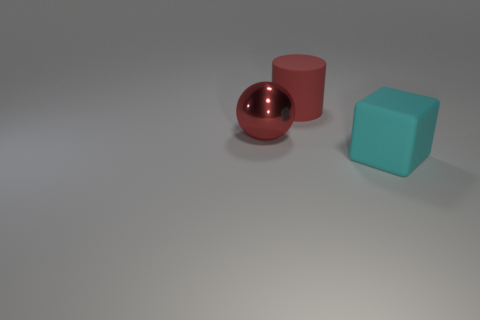Add 2 metal cylinders. How many objects exist? 5 Subtract all tiny brown cylinders. Subtract all rubber cylinders. How many objects are left? 2 Add 3 cyan cubes. How many cyan cubes are left? 4 Add 3 purple things. How many purple things exist? 3 Subtract 0 green spheres. How many objects are left? 3 Subtract all spheres. How many objects are left? 2 Subtract all cyan cylinders. Subtract all yellow spheres. How many cylinders are left? 1 